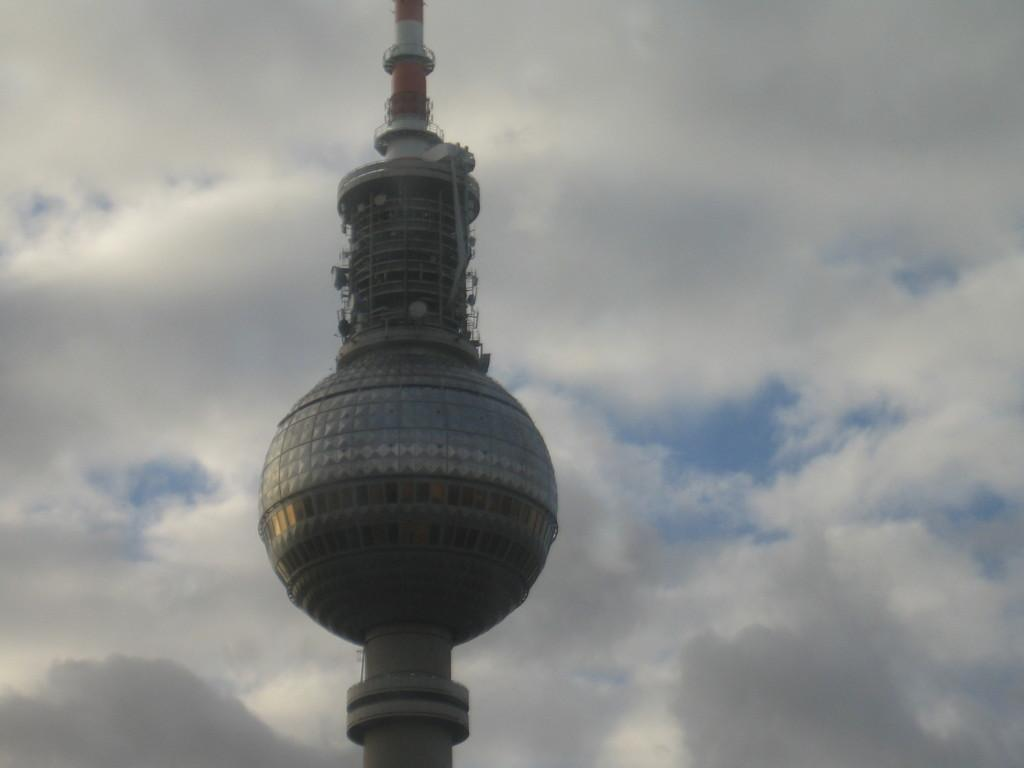What is the main object in the image? There is a pole in the image. What can be seen in the background of the image? The sky is visible in the image. How would you describe the sky in the image? The sky is cloudy in the image. Can you see a needle in the eye of the person in the image? There is no person present in the image, and therefore no eye or needle can be observed. 